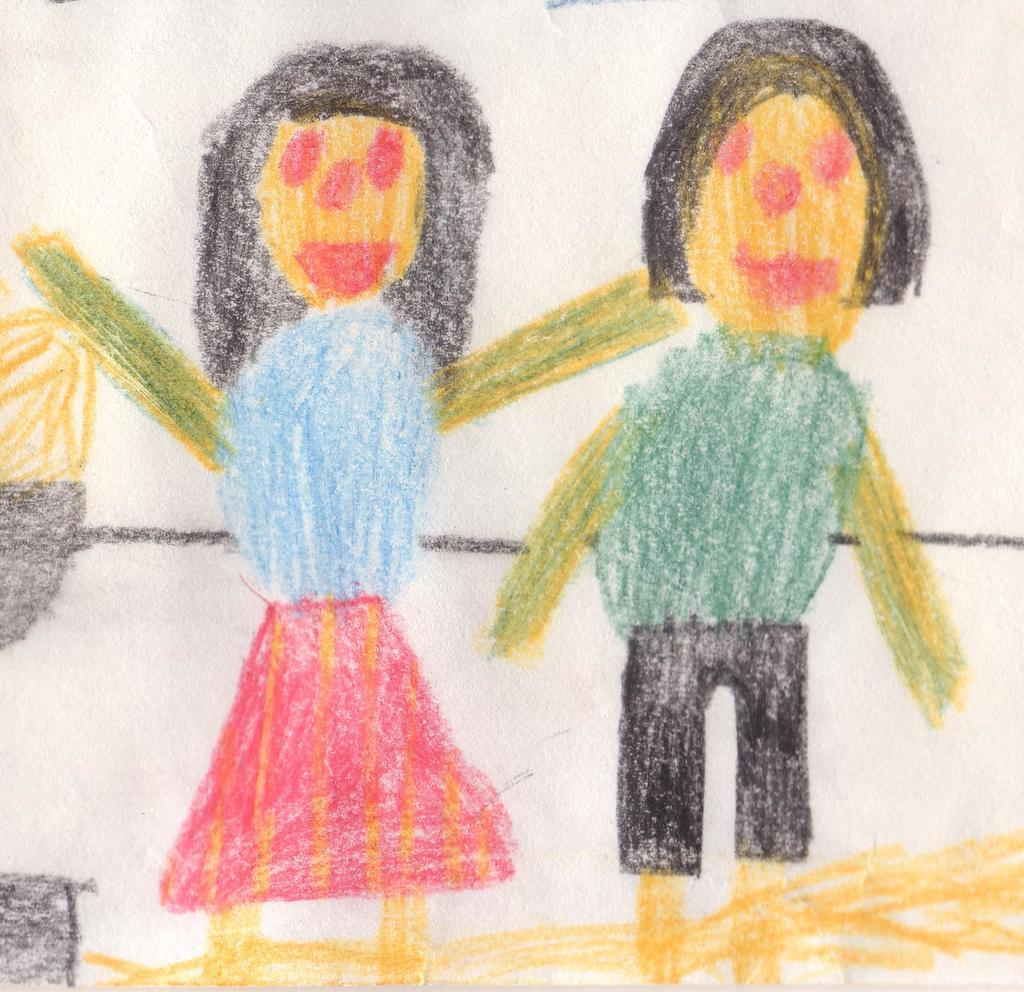How many people are present in the image? There are two persons visible in the image. What can be inferred about the medium of the image? The image appears to be a drawing on paper. What type of attack is being carried out by the persons in the image? There is no attack or any indication of violence in the image; it is a drawing of two persons. 